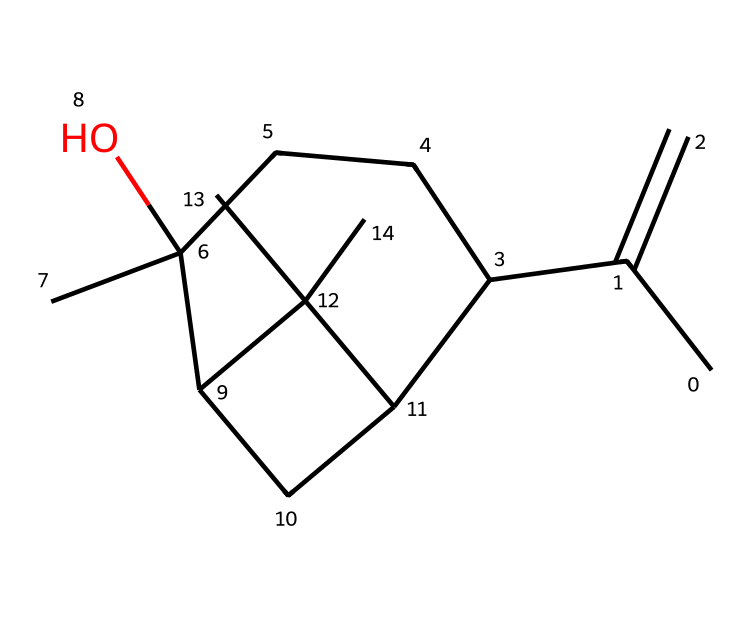What is the name of the compound represented by this SMILES notation? This SMILES notation represents the structure of a compound, which can be identified as a type of terpene found in lavender essential oil. It is known as linalool.
Answer: linalool How many carbon atoms are present in this structure? By analyzing the SMILES notation, it can be seen that there are a total of 10 carbon atoms indicated. Count the 'C' symbols in the representation.
Answer: 10 What functional group is present in this molecule? The presence of an 'O' in the structure signifies the existence of a hydroxyl group (-OH), which is characteristic of alcohols.
Answer: hydroxyl What type of hybridization is predominant among the carbon atoms in this molecule? By examining the bonding of the carbon atoms, it can be inferred that most of the carbon atoms are sp3 hybridized, as they are bonded to hydrogen and other carbons in a tetrahedral geometry.
Answer: sp3 Is this compound more likely to be a liquid or a solid at room temperature? Given that terpenes like linalool are generally liquid at room temperature due to their structure and interactions, it is reasonable to classify it as a liquid.
Answer: liquid What type of hydrocarbon does this compound belong to? This compound is classified as a terpenoid, which is a subcategory of hydrocarbons that includes terpenes due to its biosynthetic origins and structures.
Answer: terpenoid 